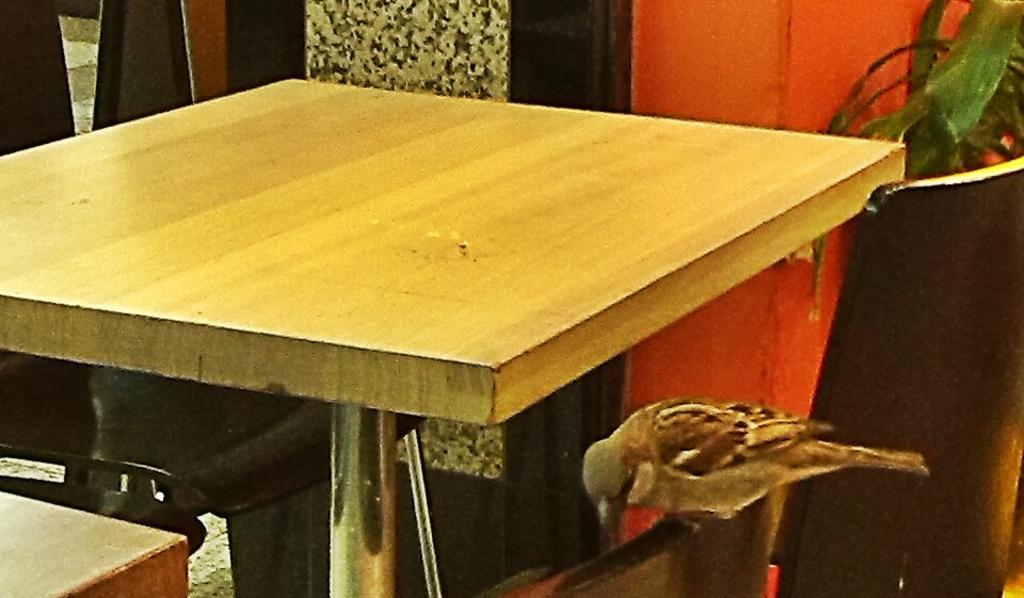Can you describe this image briefly? In the image there is a table in the middle and over the right side corner there is a bird and over the top there is a plant. 